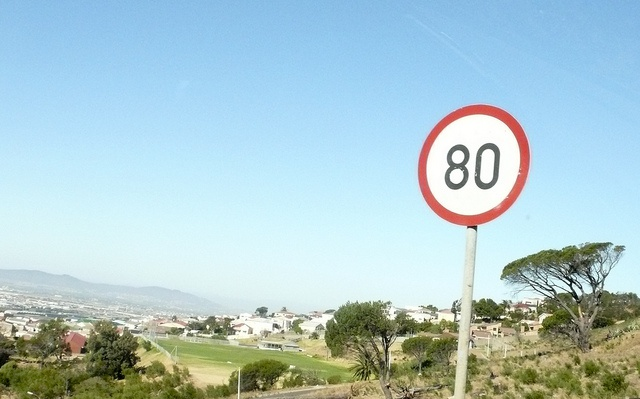Describe the objects in this image and their specific colors. I can see various objects in this image with different colors. 